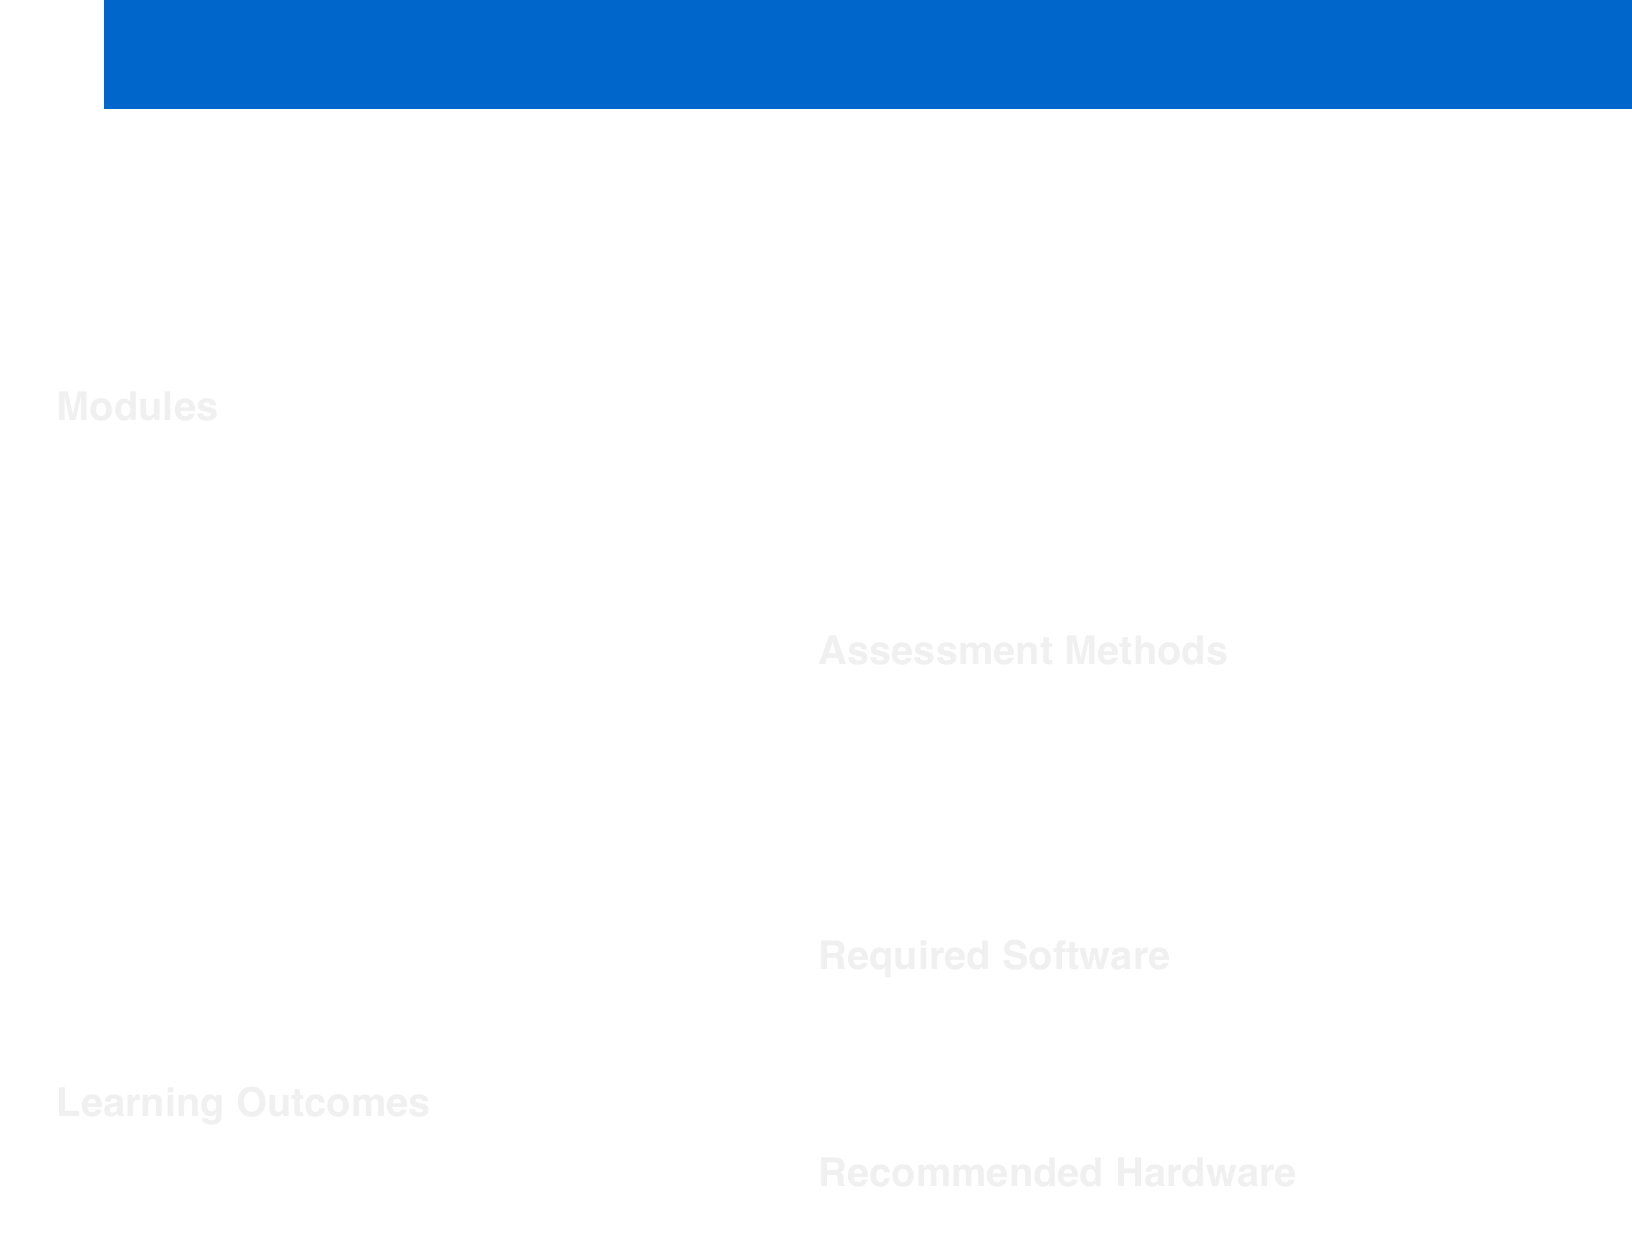What is the course code? The course code is listed at the beginning of the document, which indicates the specific identifier for the course.
Answer: SND4001 Who is the instructor for the course? The instructor's name is mentioned prominently in the course header, providing essential information about the person teaching the course.
Answer: Prof. Amelia Thornton How long is the course duration? The duration of the course is specified alongside the instructor's name, providing clarity on the time commitment required.
Answer: 15 weeks What software is required for the course? The required software is listed in the specifications section, detailing the tools needed for the course.
Answer: Wwise, FMOD, Unity or Unreal Engine, Pro Tools, Pure Data or Max/MSP What percentage of the assessment is based on practical projects? The assessment breakdown indicates the contribution of practical projects towards the overall grading, highlighting its importance.
Answer: 60% Which module focuses on immersive audio experiences? The relevant module is outlined under the modules section, showcasing the specific topic related to the immersive audio.
Answer: 3D Audio and Spatial Sound What is one of the learning outcomes of the course? One of the learning outcomes is mentioned clearly, summarizing the knowledge students are expected to acquire from the course.
Answer: Master advanced techniques in adaptive and interactive audio design What type of audio systems will students design in the Adaptive Audio Systems module? The specific type of audio systems to be designed is mentioned in the module description, reflecting the practical applications students will engage with.
Answer: Dynamic sound systems What is the format for the final portfolio presentation assessment? The final portfolio presentation is part of the assessment methods, reflecting how students will demonstrate their learning.
Answer: 20% 